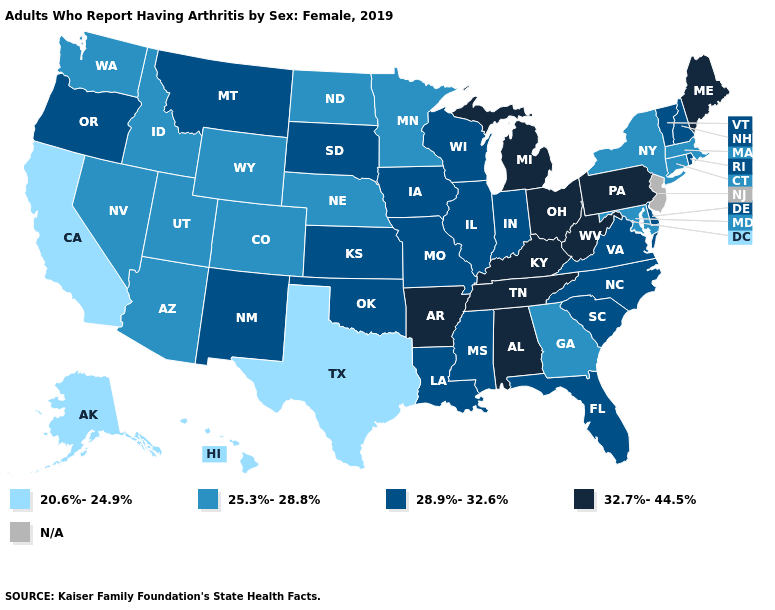What is the value of Arkansas?
Answer briefly. 32.7%-44.5%. Does the first symbol in the legend represent the smallest category?
Answer briefly. Yes. What is the highest value in states that border Oklahoma?
Quick response, please. 32.7%-44.5%. Among the states that border Nevada , does California have the lowest value?
Give a very brief answer. Yes. Name the states that have a value in the range 25.3%-28.8%?
Write a very short answer. Arizona, Colorado, Connecticut, Georgia, Idaho, Maryland, Massachusetts, Minnesota, Nebraska, Nevada, New York, North Dakota, Utah, Washington, Wyoming. Among the states that border Minnesota , which have the lowest value?
Be succinct. North Dakota. What is the value of South Dakota?
Be succinct. 28.9%-32.6%. Name the states that have a value in the range N/A?
Quick response, please. New Jersey. What is the lowest value in states that border Maine?
Keep it brief. 28.9%-32.6%. What is the value of Colorado?
Short answer required. 25.3%-28.8%. Which states hav the highest value in the West?
Keep it brief. Montana, New Mexico, Oregon. Name the states that have a value in the range 20.6%-24.9%?
Short answer required. Alaska, California, Hawaii, Texas. Does Illinois have the lowest value in the MidWest?
Keep it brief. No. Is the legend a continuous bar?
Concise answer only. No. 